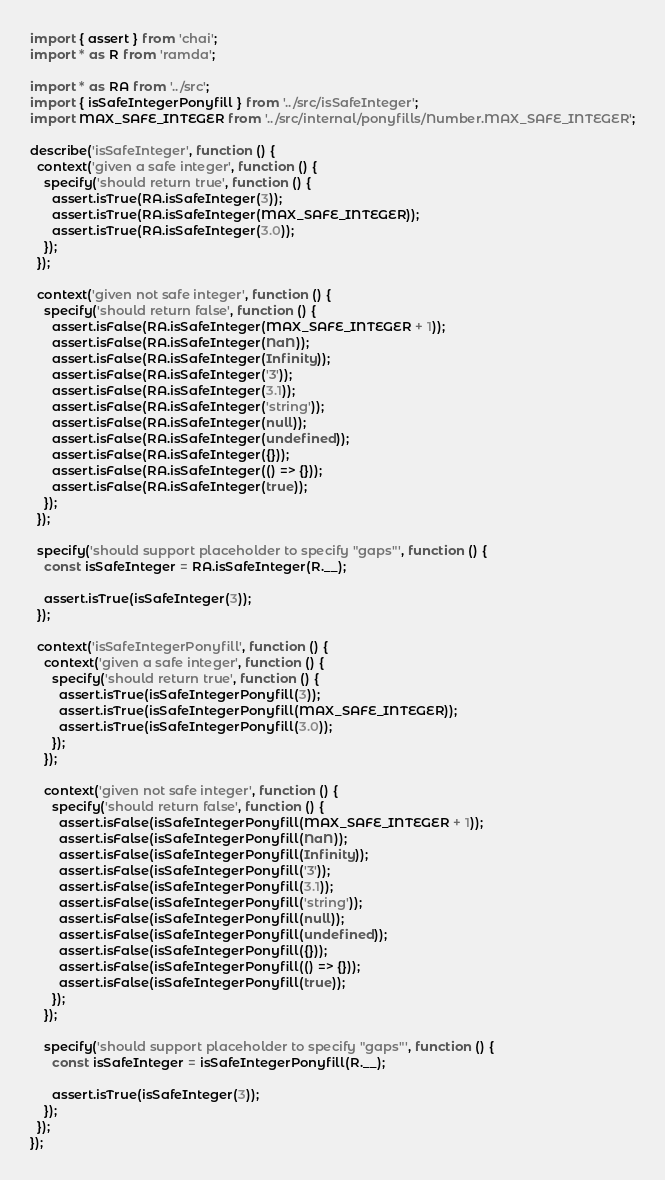<code> <loc_0><loc_0><loc_500><loc_500><_JavaScript_>import { assert } from 'chai';
import * as R from 'ramda';

import * as RA from '../src';
import { isSafeIntegerPonyfill } from '../src/isSafeInteger';
import MAX_SAFE_INTEGER from '../src/internal/ponyfills/Number.MAX_SAFE_INTEGER';

describe('isSafeInteger', function () {
  context('given a safe integer', function () {
    specify('should return true', function () {
      assert.isTrue(RA.isSafeInteger(3));
      assert.isTrue(RA.isSafeInteger(MAX_SAFE_INTEGER));
      assert.isTrue(RA.isSafeInteger(3.0));
    });
  });

  context('given not safe integer', function () {
    specify('should return false', function () {
      assert.isFalse(RA.isSafeInteger(MAX_SAFE_INTEGER + 1));
      assert.isFalse(RA.isSafeInteger(NaN));
      assert.isFalse(RA.isSafeInteger(Infinity));
      assert.isFalse(RA.isSafeInteger('3'));
      assert.isFalse(RA.isSafeInteger(3.1));
      assert.isFalse(RA.isSafeInteger('string'));
      assert.isFalse(RA.isSafeInteger(null));
      assert.isFalse(RA.isSafeInteger(undefined));
      assert.isFalse(RA.isSafeInteger({}));
      assert.isFalse(RA.isSafeInteger(() => {}));
      assert.isFalse(RA.isSafeInteger(true));
    });
  });

  specify('should support placeholder to specify "gaps"', function () {
    const isSafeInteger = RA.isSafeInteger(R.__);

    assert.isTrue(isSafeInteger(3));
  });

  context('isSafeIntegerPonyfill', function () {
    context('given a safe integer', function () {
      specify('should return true', function () {
        assert.isTrue(isSafeIntegerPonyfill(3));
        assert.isTrue(isSafeIntegerPonyfill(MAX_SAFE_INTEGER));
        assert.isTrue(isSafeIntegerPonyfill(3.0));
      });
    });

    context('given not safe integer', function () {
      specify('should return false', function () {
        assert.isFalse(isSafeIntegerPonyfill(MAX_SAFE_INTEGER + 1));
        assert.isFalse(isSafeIntegerPonyfill(NaN));
        assert.isFalse(isSafeIntegerPonyfill(Infinity));
        assert.isFalse(isSafeIntegerPonyfill('3'));
        assert.isFalse(isSafeIntegerPonyfill(3.1));
        assert.isFalse(isSafeIntegerPonyfill('string'));
        assert.isFalse(isSafeIntegerPonyfill(null));
        assert.isFalse(isSafeIntegerPonyfill(undefined));
        assert.isFalse(isSafeIntegerPonyfill({}));
        assert.isFalse(isSafeIntegerPonyfill(() => {}));
        assert.isFalse(isSafeIntegerPonyfill(true));
      });
    });

    specify('should support placeholder to specify "gaps"', function () {
      const isSafeInteger = isSafeIntegerPonyfill(R.__);

      assert.isTrue(isSafeInteger(3));
    });
  });
});
</code> 